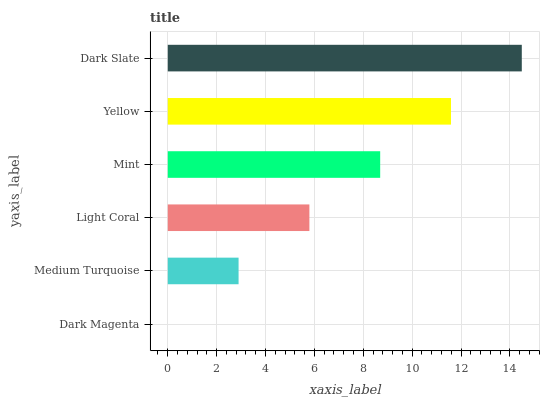Is Dark Magenta the minimum?
Answer yes or no. Yes. Is Dark Slate the maximum?
Answer yes or no. Yes. Is Medium Turquoise the minimum?
Answer yes or no. No. Is Medium Turquoise the maximum?
Answer yes or no. No. Is Medium Turquoise greater than Dark Magenta?
Answer yes or no. Yes. Is Dark Magenta less than Medium Turquoise?
Answer yes or no. Yes. Is Dark Magenta greater than Medium Turquoise?
Answer yes or no. No. Is Medium Turquoise less than Dark Magenta?
Answer yes or no. No. Is Mint the high median?
Answer yes or no. Yes. Is Light Coral the low median?
Answer yes or no. Yes. Is Medium Turquoise the high median?
Answer yes or no. No. Is Dark Magenta the low median?
Answer yes or no. No. 